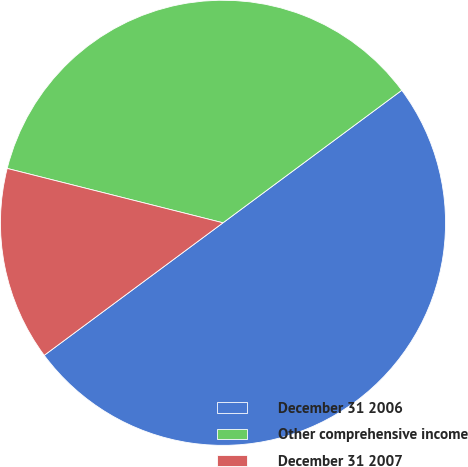Convert chart. <chart><loc_0><loc_0><loc_500><loc_500><pie_chart><fcel>December 31 2006<fcel>Other comprehensive income<fcel>December 31 2007<nl><fcel>50.0%<fcel>35.92%<fcel>14.08%<nl></chart> 